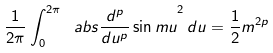Convert formula to latex. <formula><loc_0><loc_0><loc_500><loc_500>\frac { 1 } { 2 \pi } \int ^ { 2 \pi } _ { 0 } { \ a b s { \frac { d ^ { p } } { d u ^ { p } } \sin { m u } } ^ { 2 } \, d u } = \frac { 1 } { 2 } m ^ { 2 p }</formula> 